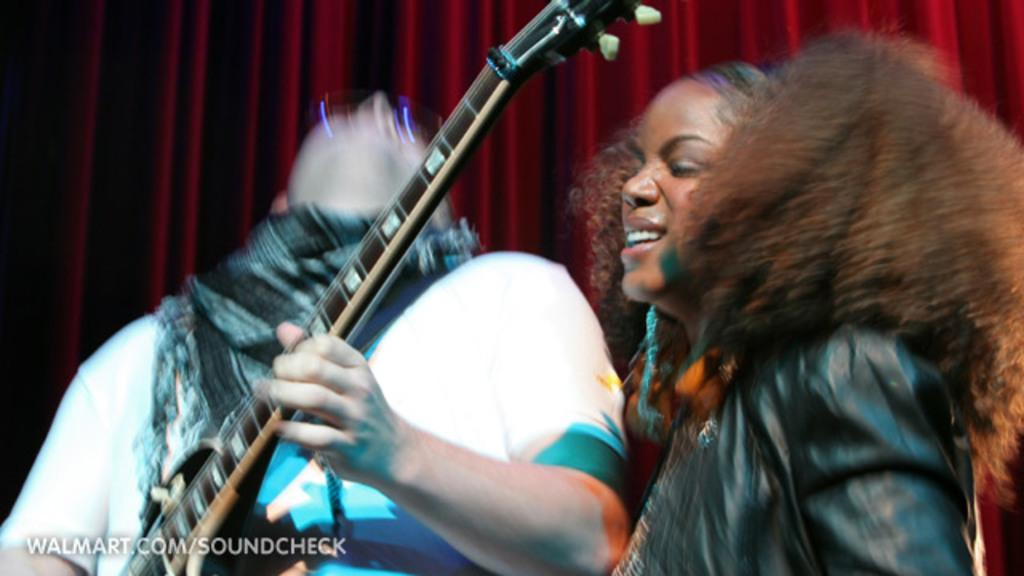What is the man in the image doing? The man is playing the guitar. Can you describe the woman's position in the image? The woman is standing at the right side of the image. How is the woman feeling in the image? The woman is laughing. What can be seen in the background of the image? There are red color curtains in the background. What is the name of the cable company that provides internet service to the people in the image? There is no information about cable companies or internet service in the image. 